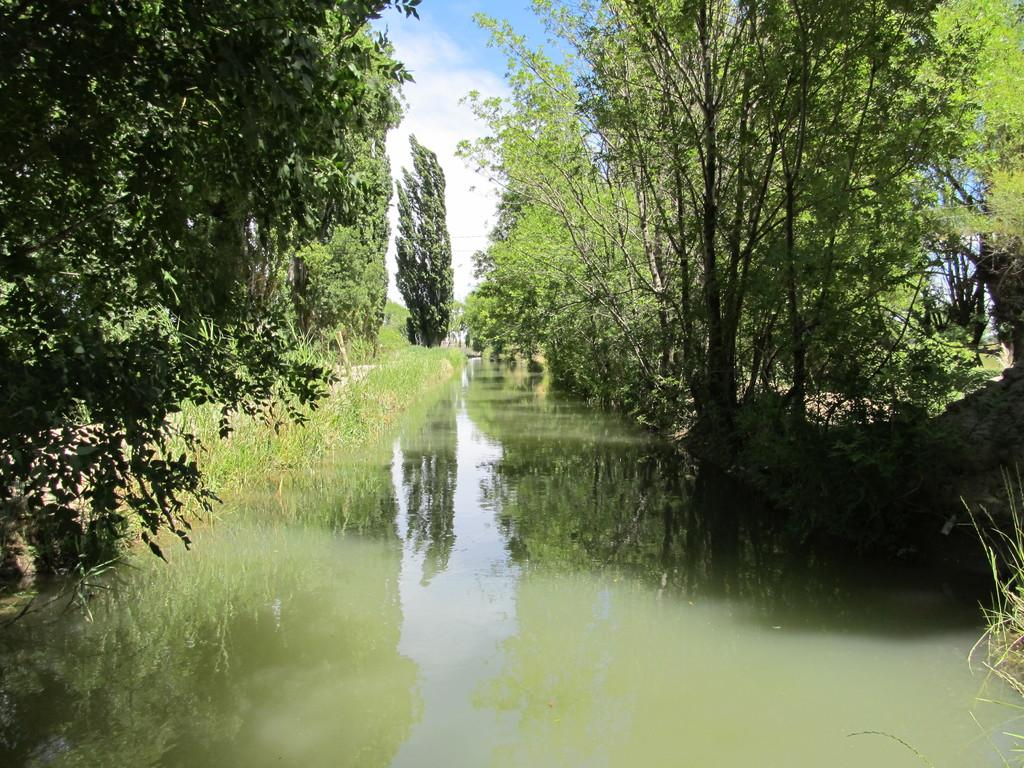Where was the picture taken? The picture was clicked outside the city. What is the main subject in the center of the image? There is a water body in the center of the image. What type of vegetation can be seen on the right side of the image? There are trees on the right side of the image. What is visible in the background of the image? The sky is visible in the background of the image. Can you see a nest in the trees on the left side of the image? There is no nest visible in the trees on the left side of the image. What theory can be applied to explain the water body in the image? The image does not provide enough information to apply any specific theory to explain the water body. 